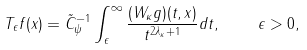<formula> <loc_0><loc_0><loc_500><loc_500>T _ { \epsilon } f ( x ) = \tilde { C } _ { \psi } ^ { - 1 } \int _ { \epsilon } ^ { \infty } \frac { ( W _ { \kappa } g ) ( t , x ) } { t ^ { 2 { \lambda _ { \kappa } } + 1 } } d t , \quad \epsilon > 0 ,</formula> 